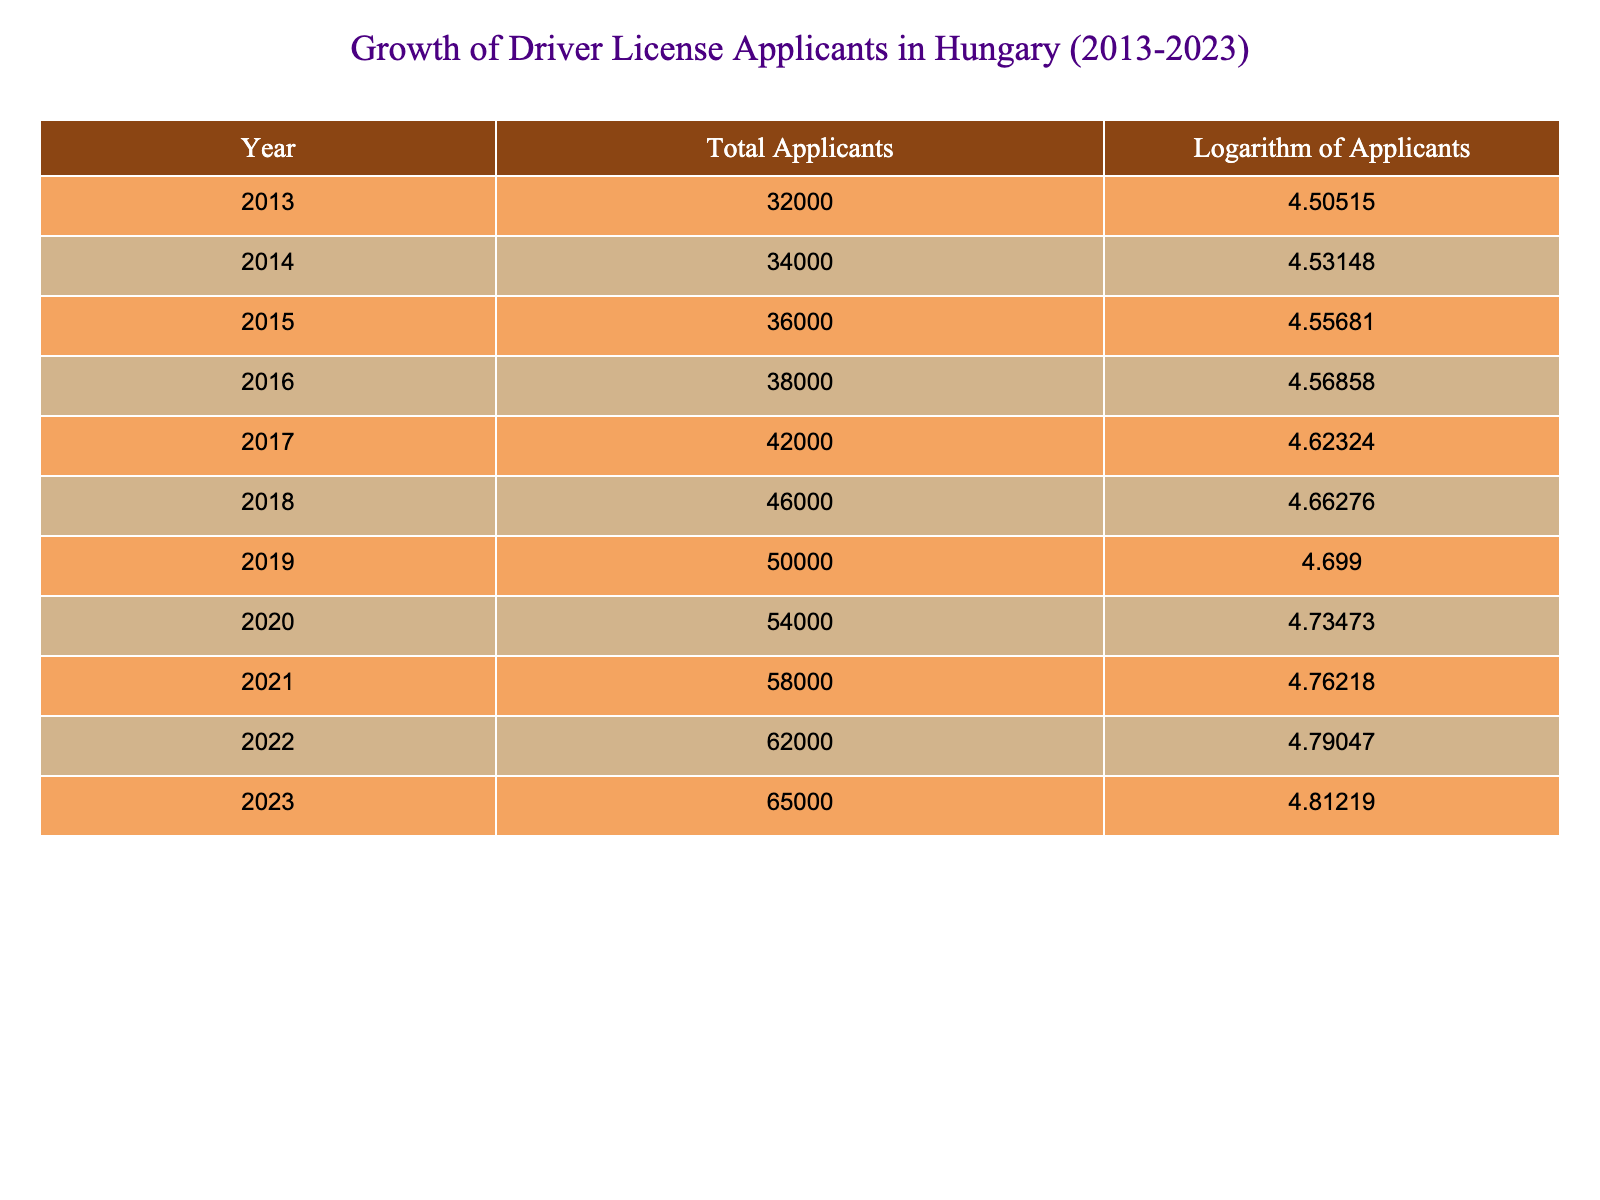What was the total number of applicants in 2015? In the table, under the "Total Applicants" column for the year 2015, the value is listed as 36000.
Answer: 36000 What is the logarithm of applicants in 2021? The table shows that for the year 2021, the logarithm of applicants is listed as 4.76218.
Answer: 4.76218 Which year had the highest number of total applicants? By examining the "Total Applicants" column, 2023 shows the highest value at 65000, making it the year with the most applicants.
Answer: 2023 What was the average number of applicants from 2013 to 2023? To find the average, add all applicants from 2013 to 2023: (32000 + 34000 + 36000 + 38000 + 42000 + 46000 + 50000 + 54000 + 58000 + 62000 + 65000) =  572000. Then, divide by the number of years (11), leading to 572000 / 11 = 52000.
Answer: 52000 Did the number of applicants increase every year from 2013 to 2023? By reviewing the "Total Applicants" column, all values from 32000 in 2013 to 65000 in 2023 show a consistent upward trend without any declines.
Answer: Yes What was the difference in the total number of applicants between 2019 and 2018? The total applicants for 2019 is 50000 and for 2018 is 46000. The difference is calculated as 50000 - 46000 = 4000.
Answer: 4000 In which year did the logarithm of applicants first exceed 4.7? By inspecting the "Logarithm of Applicants" column, it can be seen that the logarithm first exceeds 4.7 in 2020, where it is 4.73473.
Answer: 2020 How many more total applicants were there in 2022 than in 2013? The total applicants in 2022 is 62000 and in 2013 is 32000. The difference is calculated as 62000 - 32000 = 30000.
Answer: 30000 